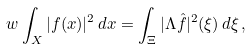<formula> <loc_0><loc_0><loc_500><loc_500>w \int _ { X } | f ( x ) | ^ { 2 } \, d x = \int _ { \Xi } | \Lambda \hat { f } | ^ { 2 } ( \xi ) \, d \xi \, ,</formula> 